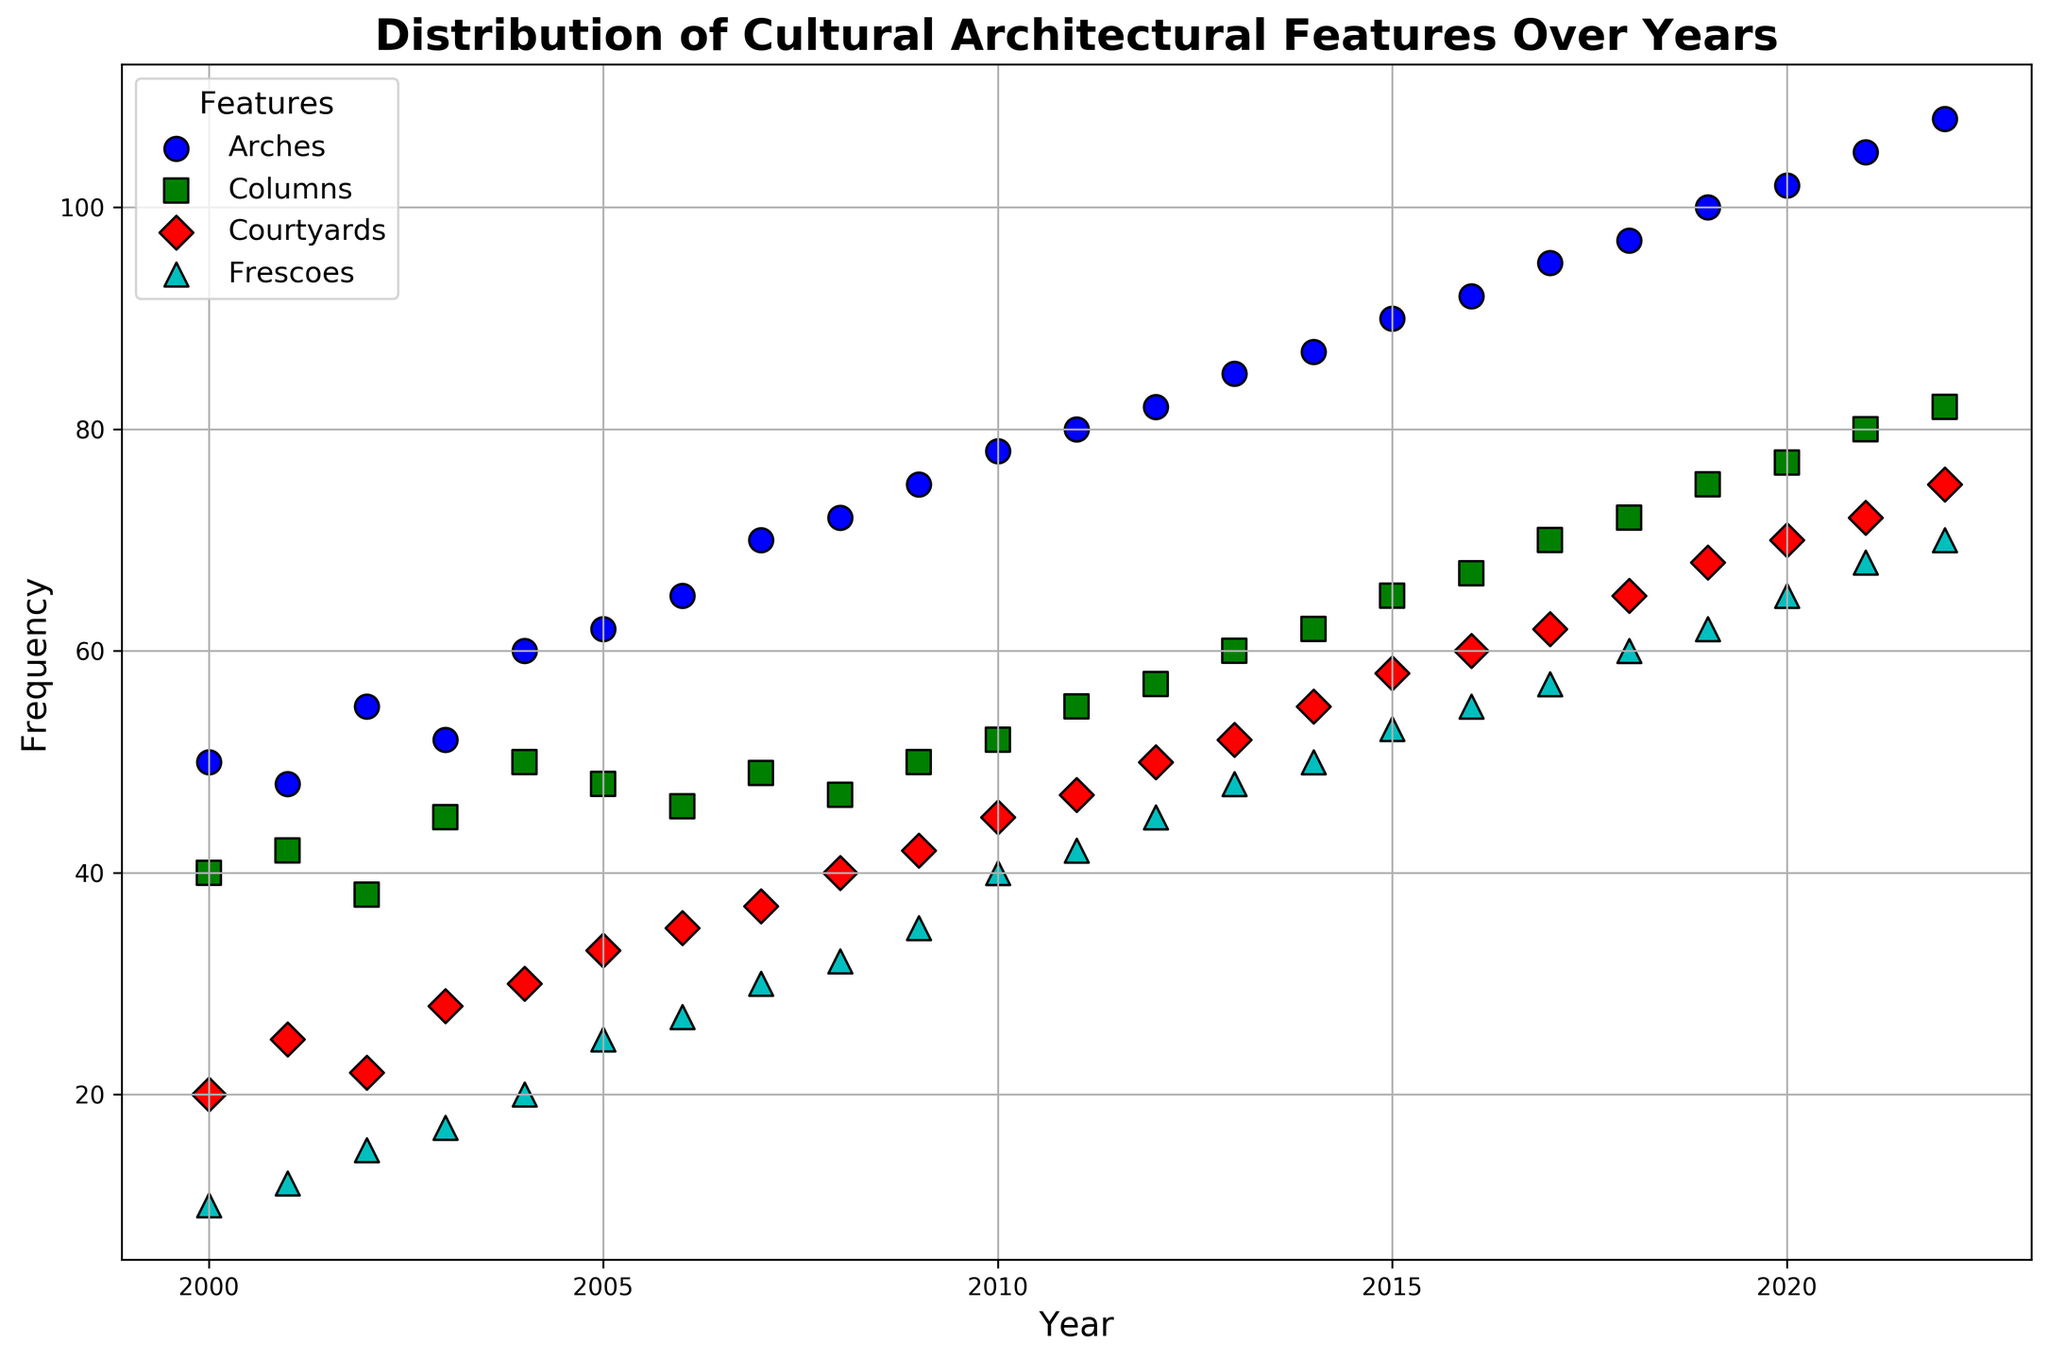What is the trend of the frequency of arches over the years? The scatter plot shows the frequency of arches increasing from the year 2000 to 2022. By observing the markers associated with arches, it's clear that they follow an upward trend.
Answer: Upward trend Which feature had the highest frequency in 2020? Looking at the scatter plot for the year 2020, we identify the highest point among all the features plotted. Arches have the highest frequency in 2020.
Answer: Arches How does the frequency of columns in 2010 compare to its frequency in 2020? By examining the markers for columns in the years 2010 and 2020, it's evident that the frequency has increased from 52 in 2010 to 77 in 2020.
Answer: Increased What is the difference in frequency of frescoes between 2005 and 2015? Locate the markers for frescoes in 2005 and 2015. The frequencies are 25 in 2005 and 53 in 2015. The difference is calculated as 53 - 25.
Answer: 28 Which cultural feature shows the most significant increase in frequency between 2000 and 2022? To determine this, compare the increase in frequency for each feature from 2000 to 2022 by subtracting the 2000 frequency from the 2022 frequency. Arches increase from 50 to 108, Columns from 40 to 82, Courtyards from 20 to 75, and Frescoes from 10 to 70. Arches have the largest increase.
Answer: Arches What is the average frequency of courtyards over the first five years (2000-2004)? Identify the frequencies of courtyards for the years 2000 to 2004: 20, 25, 22, 28, 30. Sum these values and divide by the number of years: (20 + 25 + 22 + 28 + 30) / 5.
Answer: 25 In what year did frescoes reach a frequency of 50? Check the scatter plot for markers associated with frescoes and locate the year where the frequency reaches 50. It hits 50 in 2014.
Answer: 2014 How does the frequency of courtyards in 2012 compare to that of columns in 2012? Look at the scatter plot markers for both courtyards and columns for the year 2012. Courtyards have a frequency of 50, while columns have a frequency of 57. Courtyards have a lower frequency compared to columns.
Answer: Lower What visual marker is used for columns? By observing the scatter plot legend and the markers on the plot, columns are represented by squares.
Answer: Squares 